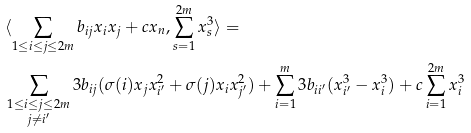<formula> <loc_0><loc_0><loc_500><loc_500>& \langle \sum _ { 1 \leq i \leq j \leq 2 m } b _ { i j } x _ { i } x _ { j } + c x _ { n } , \sum _ { s = 1 } ^ { 2 m } x _ { s } ^ { 3 } \rangle = \\ & \sum _ { \substack { 1 \leq i \leq j \leq 2 m \\ j \neq i ^ { \prime } } } 3 b _ { i j } ( \sigma ( i ) x _ { j } x _ { i ^ { \prime } } ^ { 2 } + \sigma ( j ) x _ { i } x _ { j ^ { \prime } } ^ { 2 } ) + \sum _ { i = 1 } ^ { m } 3 b _ { i i ^ { \prime } } ( x _ { i ^ { \prime } } ^ { 3 } - x _ { i } ^ { 3 } ) + c \sum _ { i = 1 } ^ { 2 m } x _ { i } ^ { 3 }</formula> 